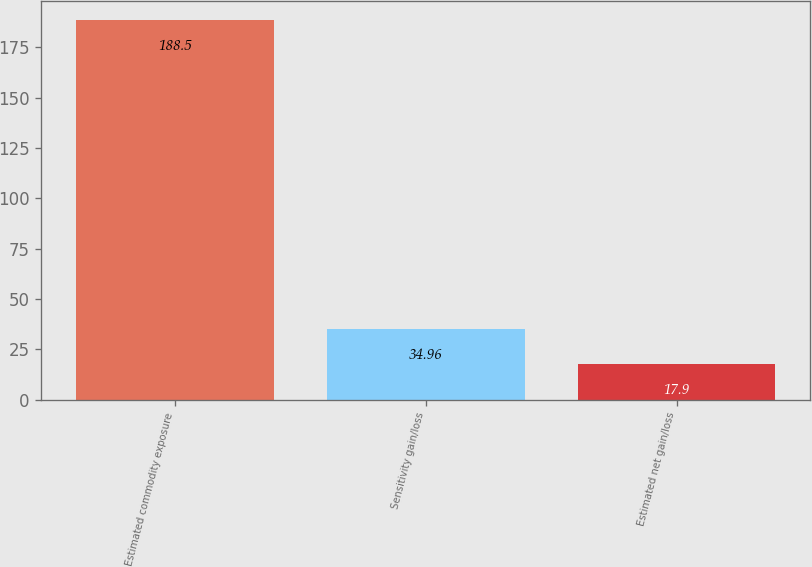<chart> <loc_0><loc_0><loc_500><loc_500><bar_chart><fcel>Estimated commodity exposure<fcel>Sensitivity gain/loss<fcel>Estimated net gain/loss<nl><fcel>188.5<fcel>34.96<fcel>17.9<nl></chart> 